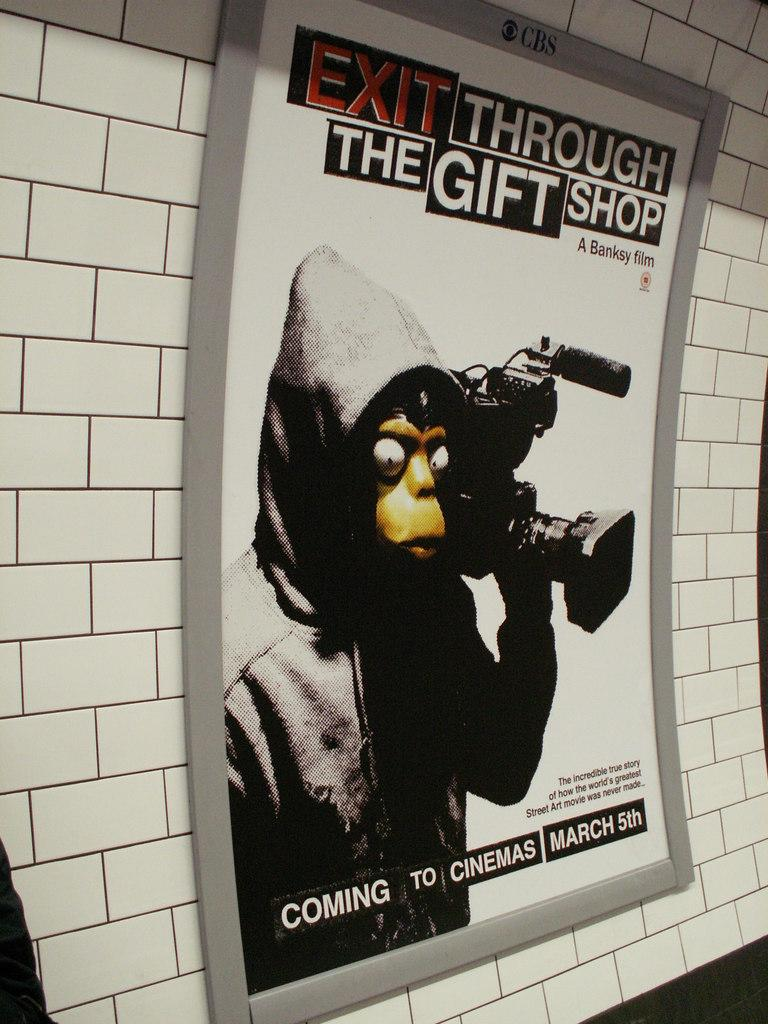What is on the wall in the image? There is a poster on the wall in the image. Can you describe the object in the left bottom corner of the image? Unfortunately, the provided facts do not give any information about the object in the left bottom corner of the image. What type of leather is used to make the fork in the image? There is no fork present in the image, and therefore no leather can be associated with it. 